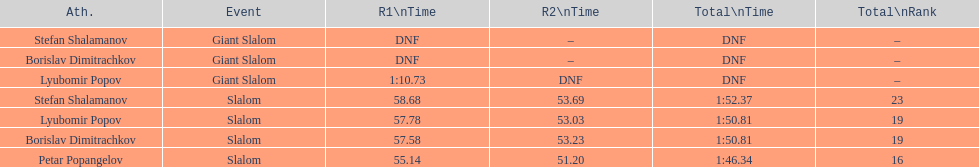What is the rank number of stefan shalamanov in the slalom event 23. 